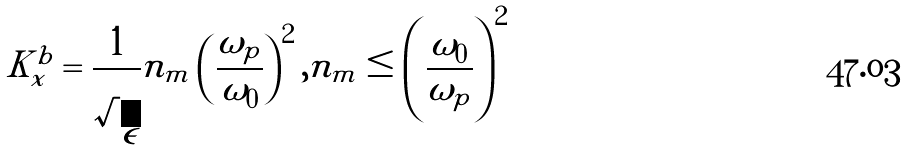Convert formula to latex. <formula><loc_0><loc_0><loc_500><loc_500>K _ { x } ^ { b } = \frac { 1 } { \sqrt { \epsilon } } n _ { m } \left ( \frac { \omega _ { p } } { \omega _ { 0 } } \right ) ^ { 2 } , n _ { m } \leq \left ( \frac { \omega _ { 0 } } { \omega _ { p } } \right ) ^ { 2 }</formula> 